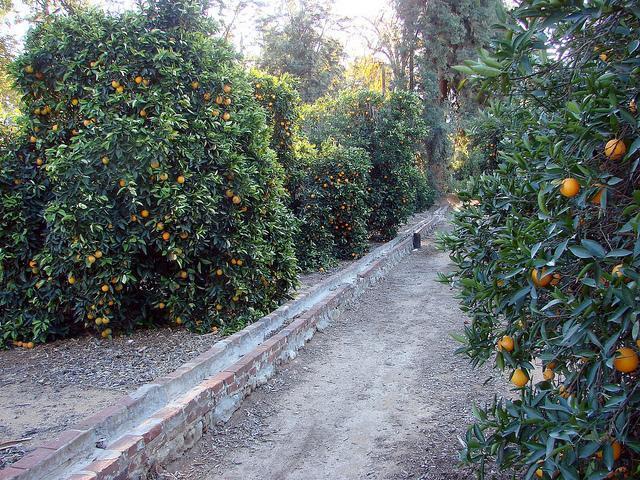What weather is greatest threat to this crop?
Choose the right answer from the provided options to respond to the question.
Options: Rain, breeze, heat, freezing. Freezing. 